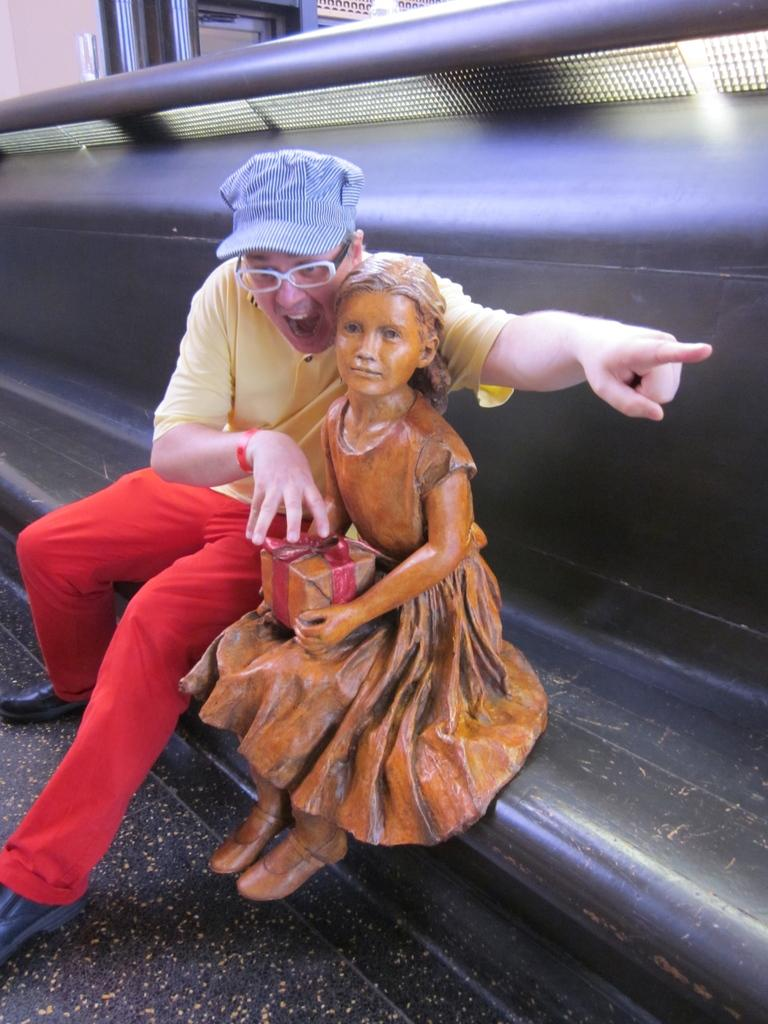What is the main subject in the foreground of the image? There is a girl's statue in the foreground of the image. What is another object or person in the foreground of the image? A person is sitting on a bench in the foreground of the image. What can be seen in the background of the image? There is a metal rod, a door, and a wall in the background of the image. Can you tell if the image was taken during the day or night? The image was likely taken during the day, as there is no indication of darkness or artificial lighting. How much dust is visible on the statue in the image? There is no mention of dust in the image, so it cannot be determined how much dust is visible on the statue. 